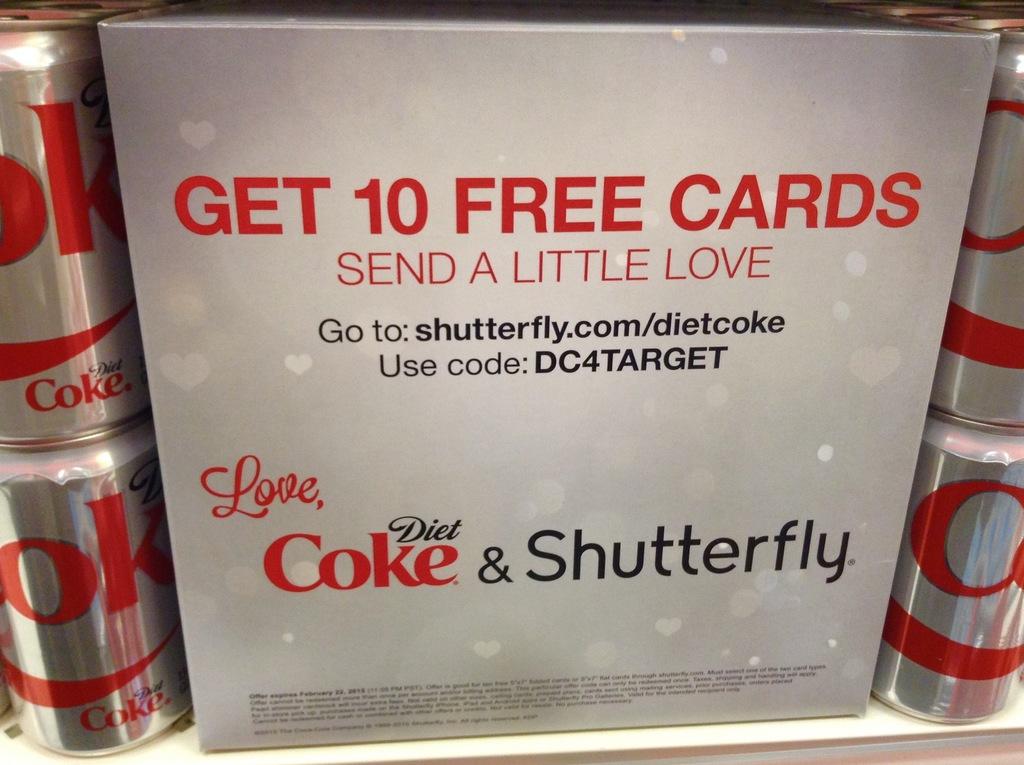What is the offer advertised?
Your answer should be very brief. Get 10 free cards. 